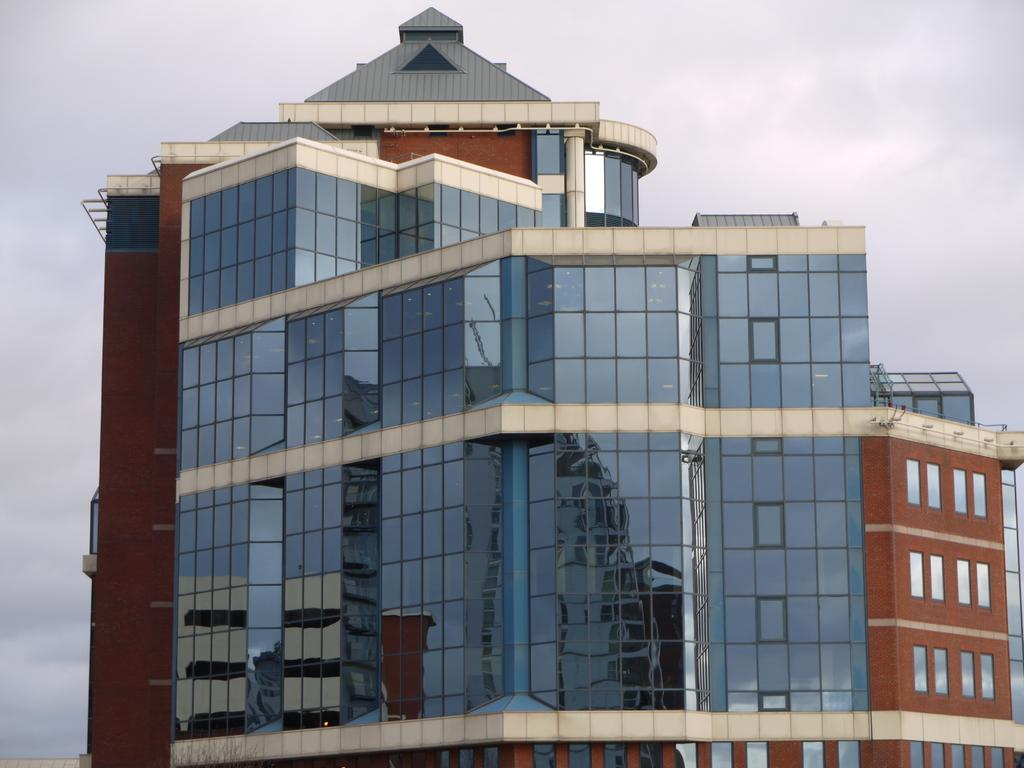What type of structure is present in the image? There is a building in the image. What can be seen in the background of the image? The sky is visible in the background of the image. How many cats are playing in the field in the image? There are no cats or fields present in the image; it features a building and the sky. 